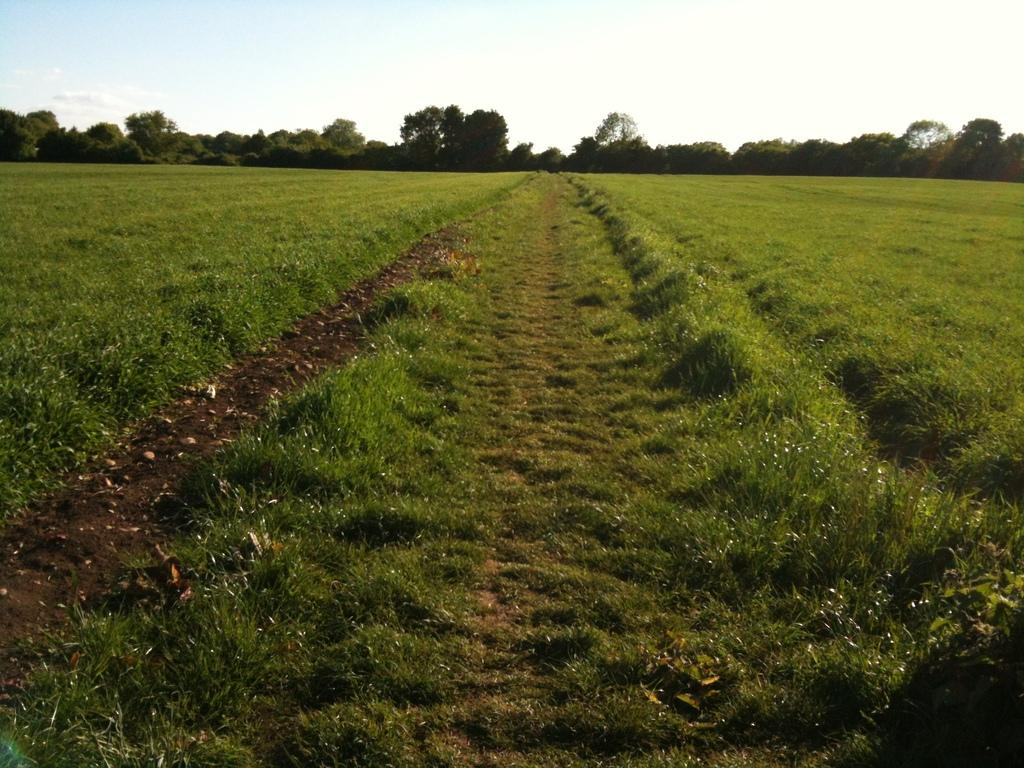What type of vegetation is in the center of the image? There is grass in the center of the image. What can be seen in the background of the image? There are trees and the sky visible in the background of the image. Can you hear a whistle in the image? There is no indication of a whistle in the image, as it is a still image and does not contain any sounds. 